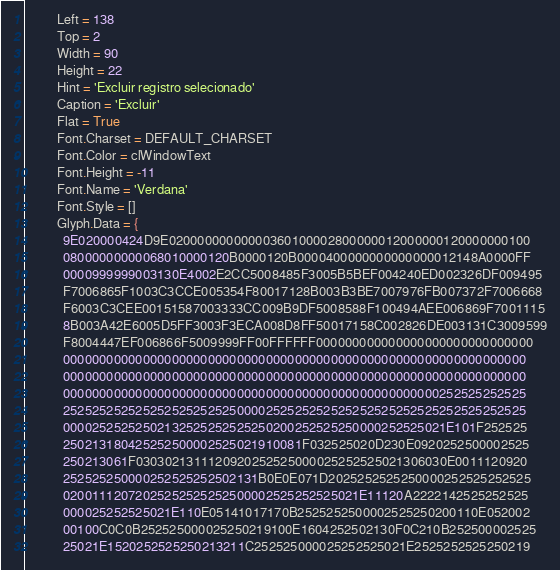Convert code to text. <code><loc_0><loc_0><loc_500><loc_500><_Pascal_>          Left = 138
          Top = 2
          Width = 90
          Height = 22
          Hint = 'Excluir registro selecionado'
          Caption = 'Excluir'
          Flat = True
          Font.Charset = DEFAULT_CHARSET
          Font.Color = clWindowText
          Font.Height = -11
          Font.Name = 'Verdana'
          Font.Style = []
          Glyph.Data = {
            9E020000424D9E02000000000000360100002800000012000000120000000100
            08000000000068010000120B0000120B0000400000000000000012148A0000FF
            0000999999003130E4002E2CC5008485F3005B5BEF004240ED002326DF009495
            F7006865F1003C3CCE005354F80017128B003B3BE7007976FB007372F7006668
            F6003C3CEE00151587003333CC009B9DF5008588F100494AEE006869F7001115
            8B003A42E6005D5FF3003F3ECA008D8FF50017158C002826DE003131C3009599
            F8004447EF006866F5009999FF00FFFFFF000000000000000000000000000000
            0000000000000000000000000000000000000000000000000000000000000000
            0000000000000000000000000000000000000000000000000000000000000000
            0000000000000000000000000000000000000000000000000000252525252525
            2525252525252525252525250000252525252525252525252525252525252525
            00002525252502132525252525250200252525250000252525021E101F252525
            250213180425252500002525021910081F032525020D230E0920252500002525
            250213061F0303021311120920252525000025252525021306030E0011120920
            252525250000252525252502131B0E0E071D2025252525250000252525252525
            02001112072025252525252500002525252525021E11120A2222142525252525
            000025252525021E110E05141017170B2525252500002525250200110E052002
            00100C0C0B252525000025250219100E1604252502130F0C210B252500002525
            25021E1520252525250213211C252525000025252525021E2525252525250219</code> 